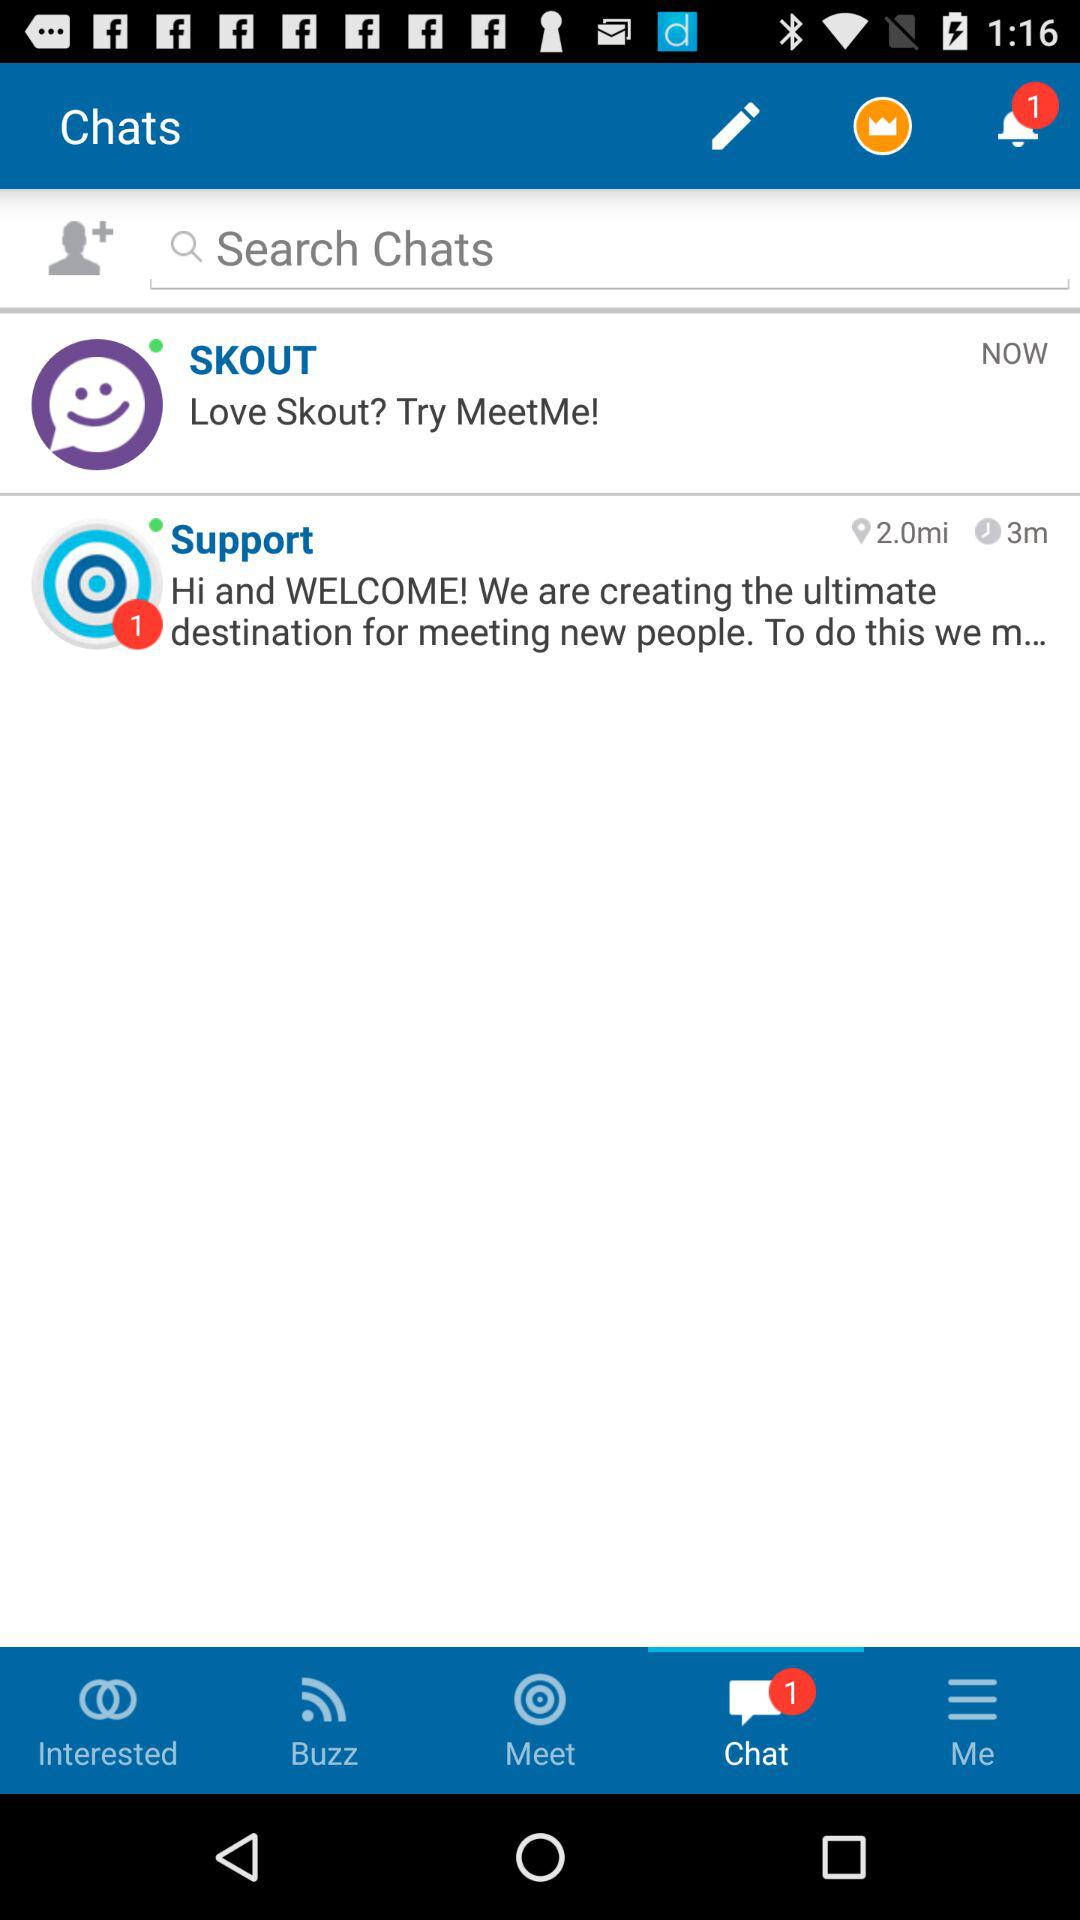At what time does Skout send a chat? Skout sends a chat " NOW". 